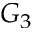Convert formula to latex. <formula><loc_0><loc_0><loc_500><loc_500>G _ { 3 }</formula> 